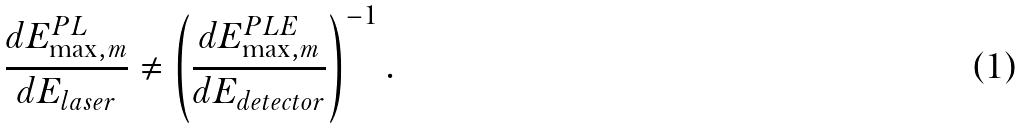<formula> <loc_0><loc_0><loc_500><loc_500>\frac { d E _ { \max , m } ^ { P L } } { d E _ { l a s e r } } \neq \left ( \frac { d E _ { \max , m } ^ { P L E } } { d E _ { d e t e c t o r } } \right ) ^ { - 1 } .</formula> 